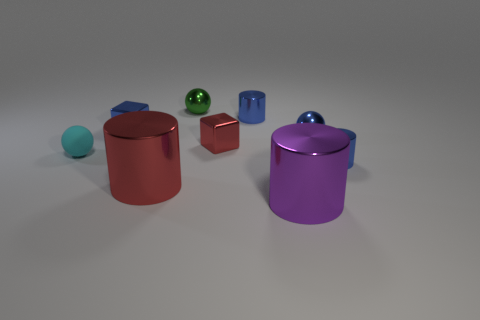What is the tiny cylinder that is behind the small blue shiny ball made of?
Give a very brief answer. Metal. There is a small metallic object in front of the sphere that is in front of the shiny ball on the right side of the large purple cylinder; what is its color?
Provide a short and direct response. Blue. What color is the thing that is the same size as the red metallic cylinder?
Your response must be concise. Purple. How many matte objects are cyan things or red balls?
Provide a short and direct response. 1. There is a sphere that is the same material as the green object; what is its color?
Keep it short and to the point. Blue. There is a small sphere on the left side of the block that is left of the small red shiny object; what is it made of?
Offer a terse response. Rubber. What number of things are either objects that are behind the purple shiny cylinder or objects on the right side of the cyan ball?
Your answer should be compact. 9. What size is the blue shiny cylinder that is left of the small blue metallic thing that is in front of the cube that is right of the green metallic thing?
Your answer should be very brief. Small. Are there the same number of green shiny spheres that are left of the small rubber object and metal cylinders?
Give a very brief answer. No. There is a green thing; is its shape the same as the tiny blue shiny thing that is on the left side of the small green shiny sphere?
Make the answer very short. No. 